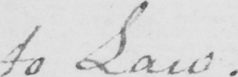What text is written in this handwritten line? to Law . 